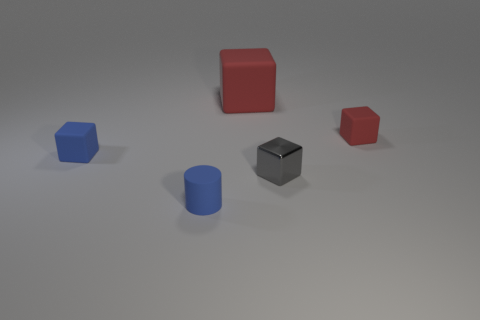Is there any other thing that is made of the same material as the tiny gray thing?
Ensure brevity in your answer.  No. There is a matte thing in front of the gray shiny cube; are there any blue rubber blocks that are on the right side of it?
Make the answer very short. No. There is a small gray metal thing; what number of tiny blue matte objects are behind it?
Your answer should be very brief. 1. What color is the other large object that is the same shape as the gray thing?
Your answer should be compact. Red. Does the blue object behind the tiny gray metal cube have the same material as the gray cube that is in front of the big red thing?
Provide a short and direct response. No. Does the big cube have the same color as the object right of the small metallic cube?
Provide a short and direct response. Yes. There is a small rubber object that is behind the cylinder and left of the small gray object; what shape is it?
Offer a terse response. Cube. How many tiny red metallic spheres are there?
Provide a short and direct response. 0. The other matte object that is the same color as the big rubber object is what shape?
Keep it short and to the point. Cube. There is another red rubber thing that is the same shape as the tiny red thing; what is its size?
Make the answer very short. Large. 